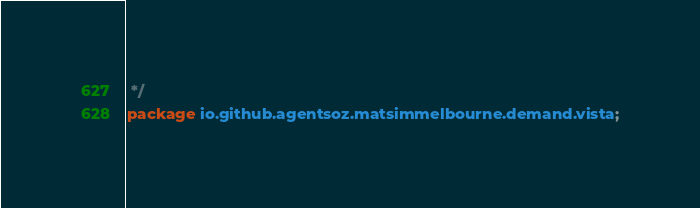Convert code to text. <code><loc_0><loc_0><loc_500><loc_500><_Java_> */
package io.github.agentsoz.matsimmelbourne.demand.vista;</code> 